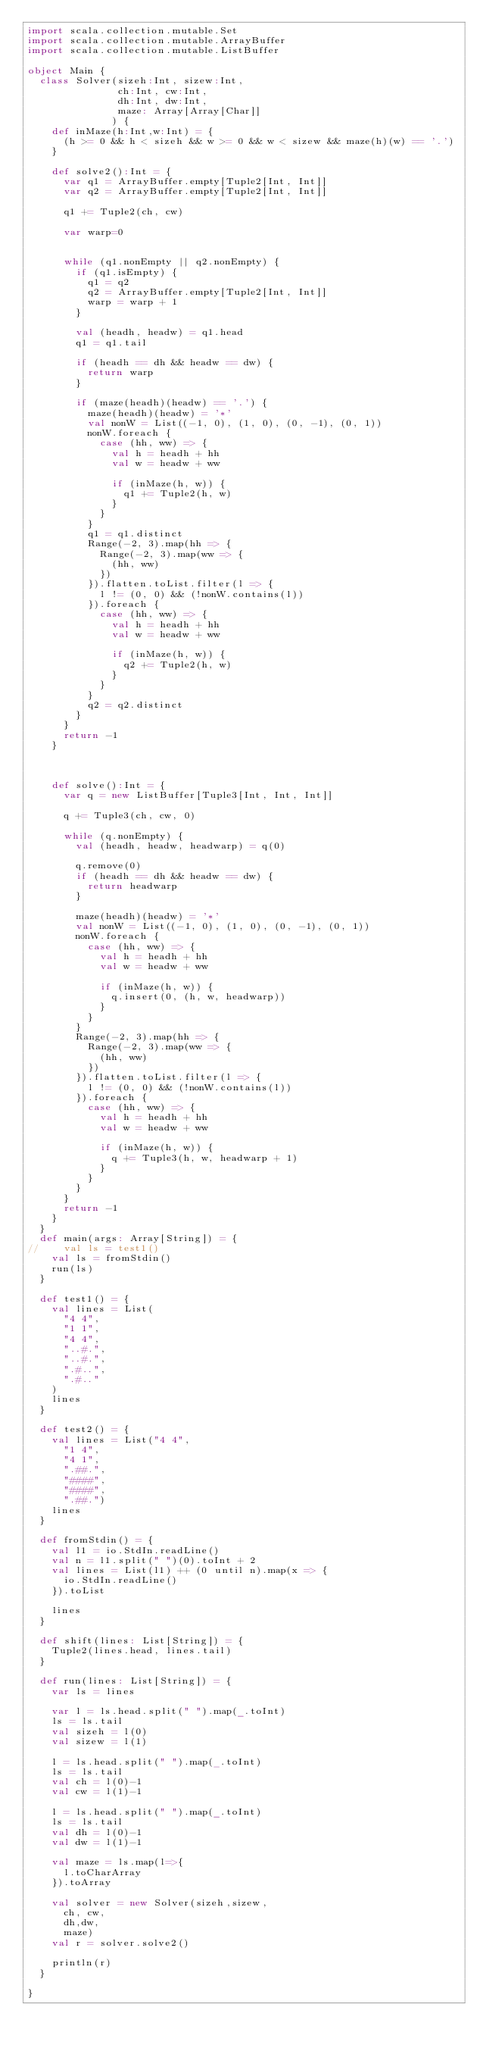Convert code to text. <code><loc_0><loc_0><loc_500><loc_500><_Scala_>import scala.collection.mutable.Set
import scala.collection.mutable.ArrayBuffer
import scala.collection.mutable.ListBuffer

object Main {
  class Solver(sizeh:Int, sizew:Int,
               ch:Int, cw:Int,
               dh:Int, dw:Int,
               maze: Array[Array[Char]]
              ) {
    def inMaze(h:Int,w:Int) = {
      (h >= 0 && h < sizeh && w >= 0 && w < sizew && maze(h)(w) == '.')
    }

    def solve2():Int = {
      var q1 = ArrayBuffer.empty[Tuple2[Int, Int]]
      var q2 = ArrayBuffer.empty[Tuple2[Int, Int]]

      q1 += Tuple2(ch, cw)

      var warp=0


      while (q1.nonEmpty || q2.nonEmpty) {
        if (q1.isEmpty) {
          q1 = q2
          q2 = ArrayBuffer.empty[Tuple2[Int, Int]]
          warp = warp + 1
        }

        val (headh, headw) = q1.head
        q1 = q1.tail

        if (headh == dh && headw == dw) {
          return warp
        }

        if (maze(headh)(headw) == '.') {
          maze(headh)(headw) = '*'
          val nonW = List((-1, 0), (1, 0), (0, -1), (0, 1))
          nonW.foreach {
            case (hh, ww) => {
              val h = headh + hh
              val w = headw + ww

              if (inMaze(h, w)) {
                q1 += Tuple2(h, w)
              }
            }
          }
          q1 = q1.distinct
          Range(-2, 3).map(hh => {
            Range(-2, 3).map(ww => {
              (hh, ww)
            })
          }).flatten.toList.filter(l => {
            l != (0, 0) && (!nonW.contains(l))
          }).foreach {
            case (hh, ww) => {
              val h = headh + hh
              val w = headw + ww

              if (inMaze(h, w)) {
                q2 += Tuple2(h, w)
              }
            }
          }
          q2 = q2.distinct
        }
      }
      return -1
    }



    def solve():Int = {
      var q = new ListBuffer[Tuple3[Int, Int, Int]]

      q += Tuple3(ch, cw, 0)

      while (q.nonEmpty) {
        val (headh, headw, headwarp) = q(0)

        q.remove(0)
        if (headh == dh && headw == dw) {
          return headwarp
        }

        maze(headh)(headw) = '*'
        val nonW = List((-1, 0), (1, 0), (0, -1), (0, 1))
        nonW.foreach {
          case (hh, ww) => {
            val h = headh + hh
            val w = headw + ww

            if (inMaze(h, w)) {
              q.insert(0, (h, w, headwarp))
            }
          }
        }
        Range(-2, 3).map(hh => {
          Range(-2, 3).map(ww => {
            (hh, ww)
          })
        }).flatten.toList.filter(l => {
          l != (0, 0) && (!nonW.contains(l))
        }).foreach {
          case (hh, ww) => {
            val h = headh + hh
            val w = headw + ww

            if (inMaze(h, w)) {
              q += Tuple3(h, w, headwarp + 1)
            }
          }
        }
      }
      return -1
    }
  }
  def main(args: Array[String]) = {
//    val ls = test1()
    val ls = fromStdin()
    run(ls)
  }

  def test1() = {
    val lines = List(
      "4 4",
      "1 1",
      "4 4",
      "..#.",
      "..#.",
      ".#..",
      ".#.."
    )
    lines
  }

  def test2() = {
    val lines = List("4 4",
      "1 4",
      "4 1",
      ".##.",
      "####",
      "####",
      ".##.")
    lines
  }

  def fromStdin() = {
    val l1 = io.StdIn.readLine()
    val n = l1.split(" ")(0).toInt + 2
    val lines = List(l1) ++ (0 until n).map(x => {
      io.StdIn.readLine()
    }).toList

    lines
  }

  def shift(lines: List[String]) = {
    Tuple2(lines.head, lines.tail)
  }

  def run(lines: List[String]) = {
    var ls = lines

    var l = ls.head.split(" ").map(_.toInt)
    ls = ls.tail
    val sizeh = l(0)
    val sizew = l(1)

    l = ls.head.split(" ").map(_.toInt)
    ls = ls.tail
    val ch = l(0)-1
    val cw = l(1)-1

    l = ls.head.split(" ").map(_.toInt)
    ls = ls.tail
    val dh = l(0)-1
    val dw = l(1)-1

    val maze = ls.map(l=>{
      l.toCharArray
    }).toArray

    val solver = new Solver(sizeh,sizew,
      ch, cw,
      dh,dw,
      maze)
    val r = solver.solve2()

    println(r)
  }

}
</code> 